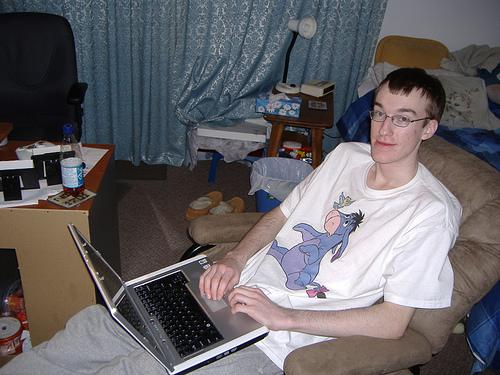Which children's author's creation does this man show off? eeyore 